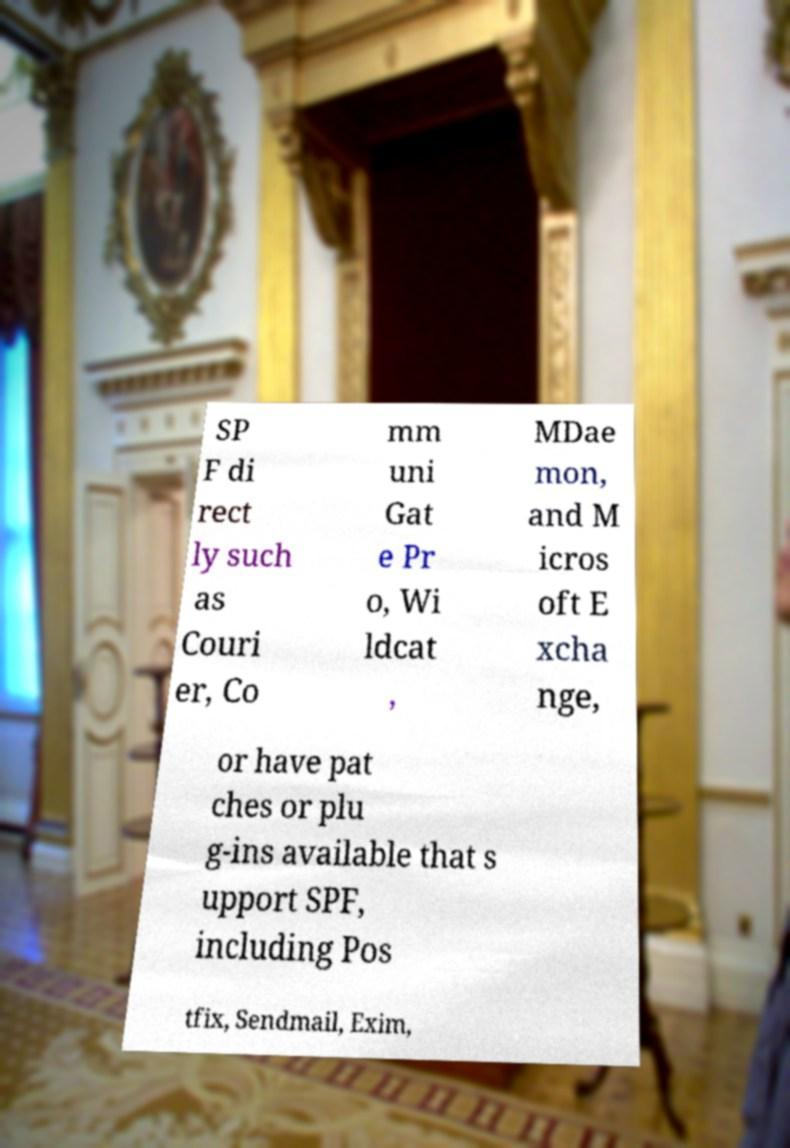Could you assist in decoding the text presented in this image and type it out clearly? SP F di rect ly such as Couri er, Co mm uni Gat e Pr o, Wi ldcat , MDae mon, and M icros oft E xcha nge, or have pat ches or plu g-ins available that s upport SPF, including Pos tfix, Sendmail, Exim, 